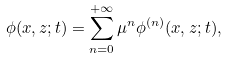<formula> <loc_0><loc_0><loc_500><loc_500>\phi ( x , z ; t ) = \sum _ { n = 0 } ^ { + \infty } \mu ^ { n } \phi ^ { ( n ) } ( x , z ; t ) ,</formula> 